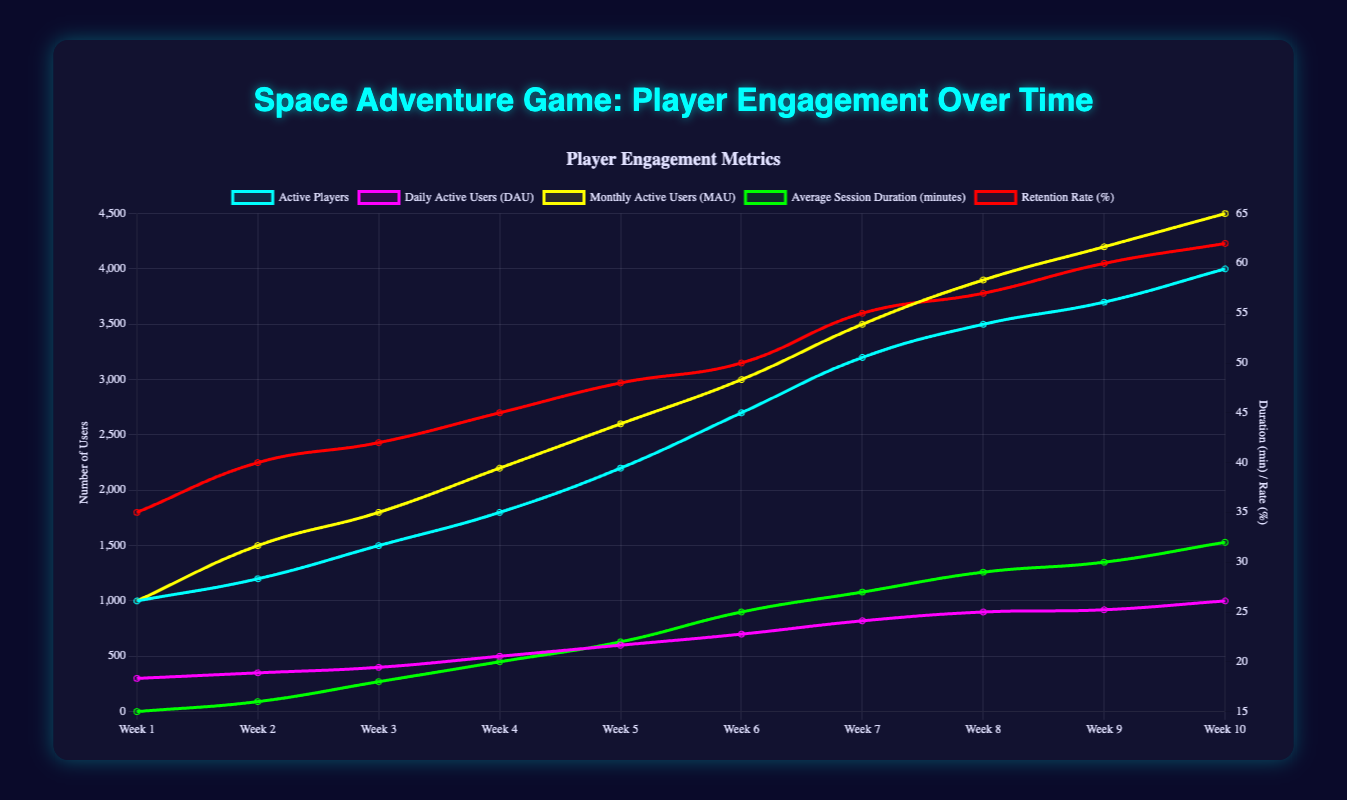What is the total number of active players by Week 10? Sum up the data points for 'Active Players' from Week 1 to Week 10: 1000 + 1200 + 1500 + 1800 + 2200 + 2700 + 3200 + 3500 + 3700 + 4000 = 24800
Answer: 24800 Which feature has the highest usage increase from Week 1 to Week 10? Compare the increase in usage for each feature from Week 1 to Week 10. The increase for 'Space Missions' is 2300 - 500 = 1800, for 'PvP Battles' is 540 - 150 = 390, for 'Trading' is 800 - 300 = 500, for 'Exploration' is 1000 - 200 = 800, for 'Customization' is 400 - 100 = 300, for 'Base Building' is 275 - 50 = 225.
Answer: Space Missions Which metric had the highest variability over time and how is it visually represented in the chart? Examine the fluctuations in the data lines for each metric. 'Active Players' trend shows significant rises, likely the highest variability shown by the steepness and height of the blue line.
Answer: Active Players What is the average session duration in Week 5 and Week 10? Average Session Duration in Week 5 is 22 minutes, and in Week 10 is 32 minutes.
Answer: 27 Between PvP Battles and Customization, which one had more overall usage by Week 5? Sum the usage from Week 1 to Week 5 for both features. PvP Battles: 150 + 180 + 210 + 280 + 350 = 1170, Customization: 100 + 110 + 130 + 160 + 200 = 700. PvP Battles had more usage.
Answer: PvP Battles 